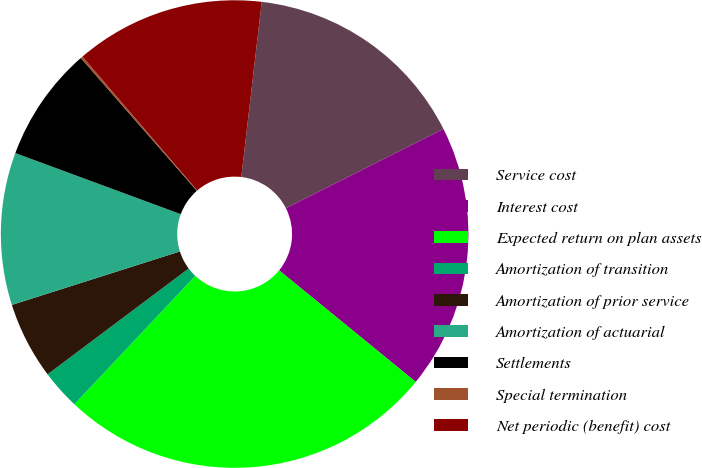Convert chart to OTSL. <chart><loc_0><loc_0><loc_500><loc_500><pie_chart><fcel>Service cost<fcel>Interest cost<fcel>Expected return on plan assets<fcel>Amortization of transition<fcel>Amortization of prior service<fcel>Amortization of actuarial<fcel>Settlements<fcel>Special termination<fcel>Net periodic (benefit) cost<nl><fcel>15.73%<fcel>18.32%<fcel>26.12%<fcel>2.74%<fcel>5.34%<fcel>10.53%<fcel>7.94%<fcel>0.15%<fcel>13.13%<nl></chart> 